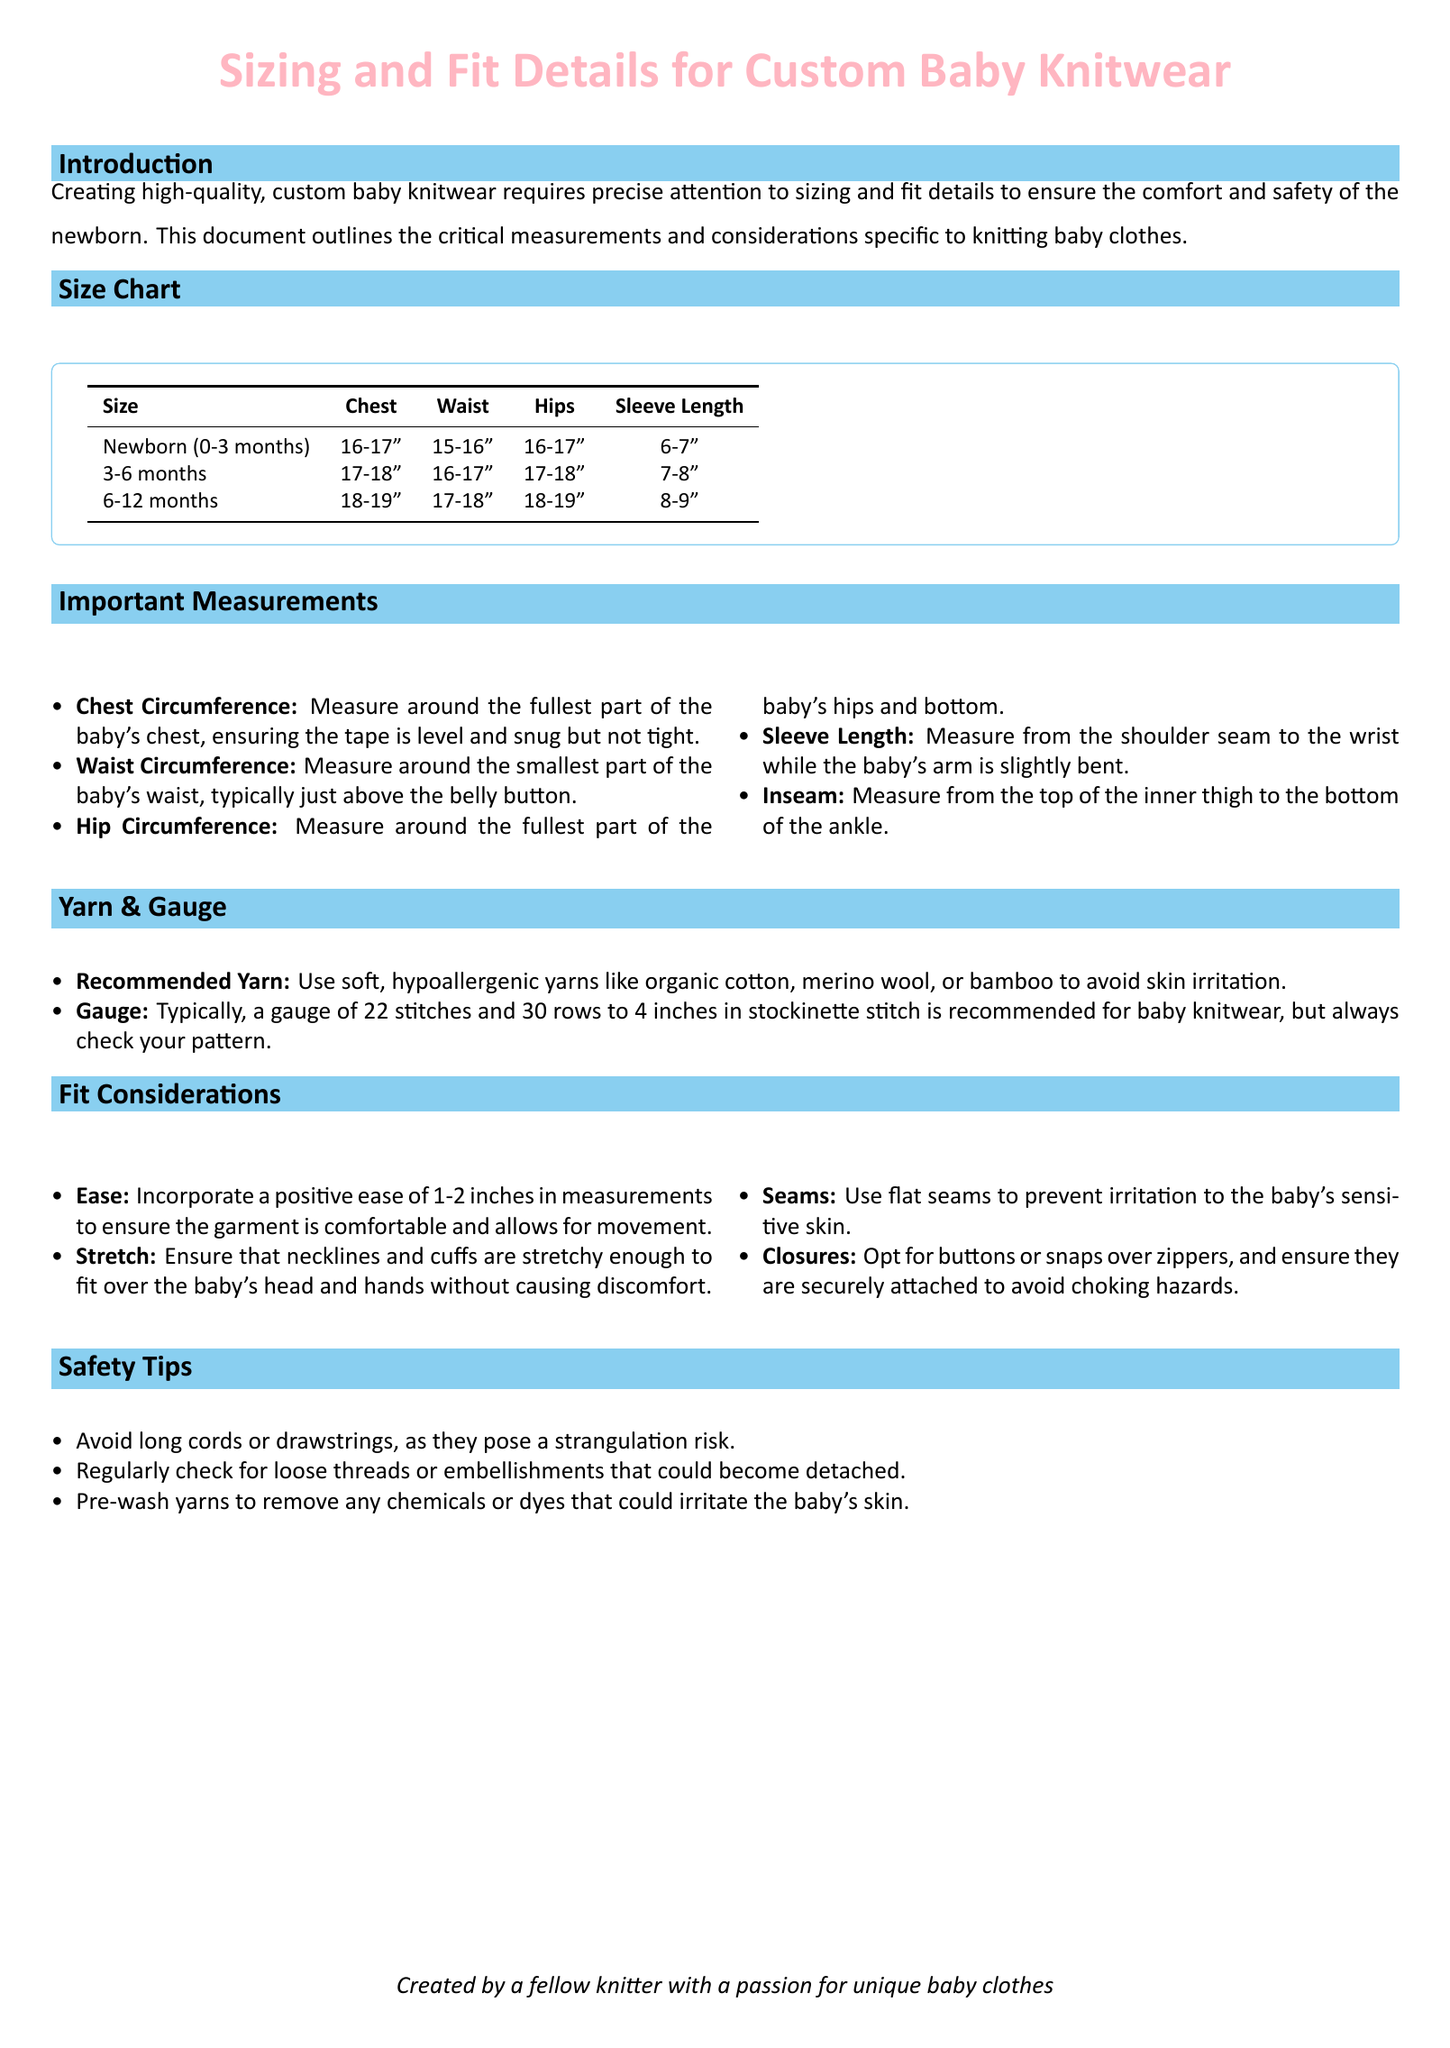what is the chest measurement for a 6-12 month size? The chest measurement for 6-12 months is listed in the size chart as 18-19 inches.
Answer: 18-19" what is the recommended yarn type for baby knitwear? The document specifies using soft, hypoallergenic yarns such as organic cotton, merino wool, or bamboo.
Answer: Organic cotton, merino wool, or bamboo what is the typical gauge for baby knitwear? The typical gauge recommended for baby knitwear is 22 stitches and 30 rows to 4 inches in stockinette stitch.
Answer: 22 stitches and 30 rows what is the sleeve length for a newborn size? The sleeve length for a newborn size is stated in the size chart as 6-7 inches.
Answer: 6-7" how much positive ease should be incorporated in measurements? The document states that a positive ease of 1-2 inches should be incorporated for comfort.
Answer: 1-2 inches why is it advisable to use flat seams in baby knitwear? The document mentions flat seams to prevent irritation to the baby's sensitive skin.
Answer: To prevent irritation how should necklines and cuffs be designed? The document suggests that necklines and cuffs should be stretchy enough to fit without discomfort.
Answer: Stretchy enough what is one safety tip provided in the document? The document advises avoiding long cords or drawstrings to prevent strangulation risks.
Answer: Avoid long cords or drawstrings what measurement is taken from the shoulder seam to the wrist? This measurement is referred to as Sleeve Length.
Answer: Sleeve Length what is the hip measurement for a 3-6 month size? The hip measurement for a 3-6 month size is noted as 17-18 inches.
Answer: 17-18" 